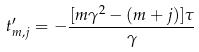<formula> <loc_0><loc_0><loc_500><loc_500>t ^ { \prime } _ { m , j } = - \frac { [ m \gamma ^ { 2 } - ( m + j ) ] \tau } { \gamma }</formula> 